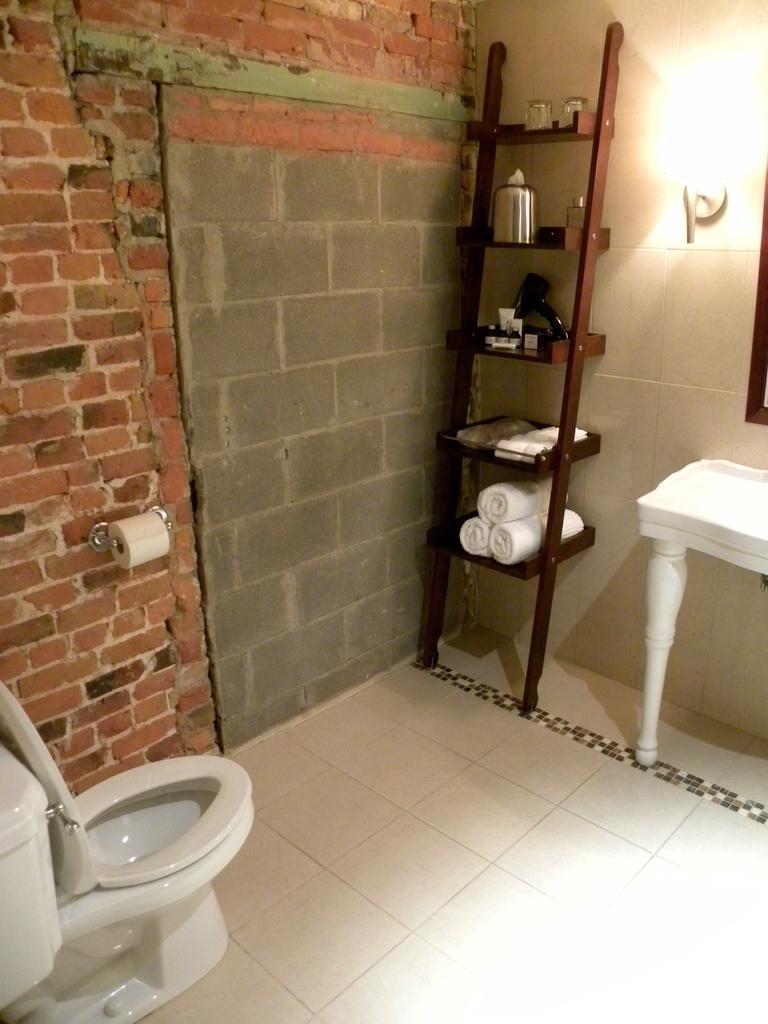Could you give a brief overview of what you see in this image? This is a picture of a image taken in a house this looking like a toilet and the floor is covered with white tiles on the floor there is a shelf on the shelf there is a towels, glass. Background of this is a wall. 